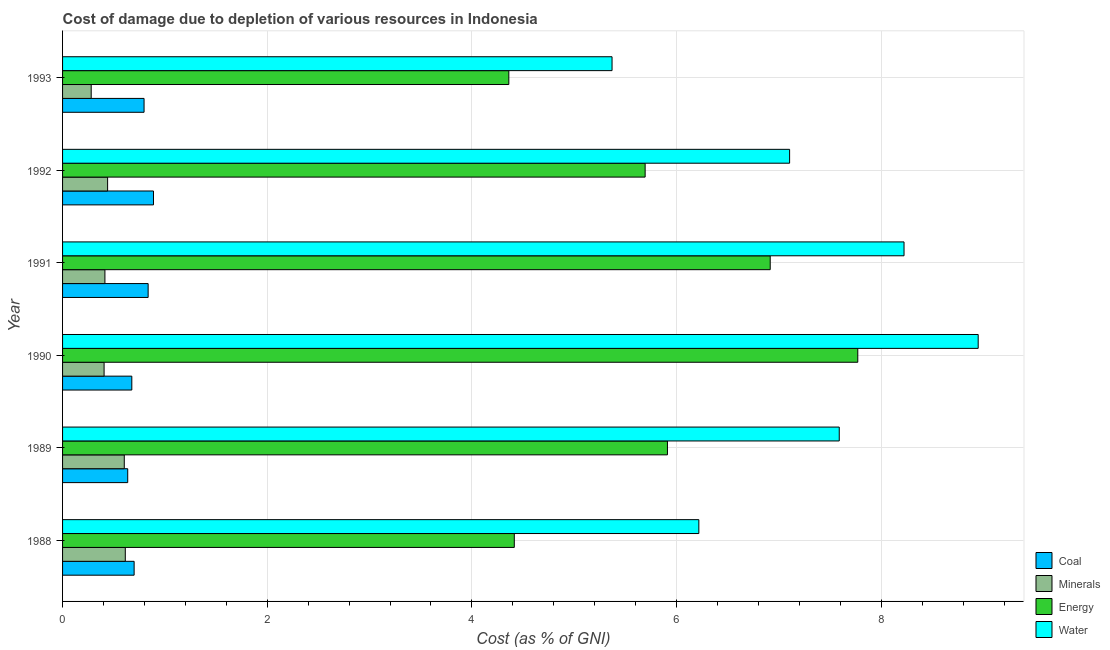How many different coloured bars are there?
Your answer should be very brief. 4. How many groups of bars are there?
Provide a succinct answer. 6. How many bars are there on the 5th tick from the bottom?
Make the answer very short. 4. What is the cost of damage due to depletion of water in 1990?
Give a very brief answer. 8.95. Across all years, what is the maximum cost of damage due to depletion of minerals?
Your response must be concise. 0.61. Across all years, what is the minimum cost of damage due to depletion of water?
Provide a succinct answer. 5.37. What is the total cost of damage due to depletion of coal in the graph?
Your response must be concise. 4.53. What is the difference between the cost of damage due to depletion of minerals in 1990 and that in 1993?
Provide a succinct answer. 0.13. What is the difference between the cost of damage due to depletion of minerals in 1992 and the cost of damage due to depletion of coal in 1993?
Your answer should be very brief. -0.36. What is the average cost of damage due to depletion of coal per year?
Give a very brief answer. 0.76. In the year 1988, what is the difference between the cost of damage due to depletion of energy and cost of damage due to depletion of coal?
Keep it short and to the point. 3.71. What is the ratio of the cost of damage due to depletion of energy in 1990 to that in 1991?
Provide a succinct answer. 1.12. Is the cost of damage due to depletion of minerals in 1990 less than that in 1992?
Offer a terse response. Yes. Is the difference between the cost of damage due to depletion of coal in 1988 and 1992 greater than the difference between the cost of damage due to depletion of energy in 1988 and 1992?
Your answer should be compact. Yes. What is the difference between the highest and the second highest cost of damage due to depletion of minerals?
Keep it short and to the point. 0.01. Is the sum of the cost of damage due to depletion of energy in 1988 and 1990 greater than the maximum cost of damage due to depletion of coal across all years?
Keep it short and to the point. Yes. Is it the case that in every year, the sum of the cost of damage due to depletion of minerals and cost of damage due to depletion of coal is greater than the sum of cost of damage due to depletion of energy and cost of damage due to depletion of water?
Keep it short and to the point. No. What does the 1st bar from the top in 1993 represents?
Your answer should be very brief. Water. What does the 2nd bar from the bottom in 1990 represents?
Your answer should be very brief. Minerals. Is it the case that in every year, the sum of the cost of damage due to depletion of coal and cost of damage due to depletion of minerals is greater than the cost of damage due to depletion of energy?
Your answer should be very brief. No. How many bars are there?
Make the answer very short. 24. Are the values on the major ticks of X-axis written in scientific E-notation?
Offer a very short reply. No. Does the graph contain any zero values?
Your answer should be very brief. No. What is the title of the graph?
Provide a short and direct response. Cost of damage due to depletion of various resources in Indonesia . What is the label or title of the X-axis?
Your answer should be very brief. Cost (as % of GNI). What is the Cost (as % of GNI) of Coal in 1988?
Provide a short and direct response. 0.7. What is the Cost (as % of GNI) of Minerals in 1988?
Your answer should be very brief. 0.61. What is the Cost (as % of GNI) in Energy in 1988?
Offer a terse response. 4.41. What is the Cost (as % of GNI) of Water in 1988?
Keep it short and to the point. 6.22. What is the Cost (as % of GNI) of Coal in 1989?
Offer a terse response. 0.64. What is the Cost (as % of GNI) in Minerals in 1989?
Ensure brevity in your answer.  0.6. What is the Cost (as % of GNI) of Energy in 1989?
Keep it short and to the point. 5.91. What is the Cost (as % of GNI) of Water in 1989?
Make the answer very short. 7.59. What is the Cost (as % of GNI) in Coal in 1990?
Make the answer very short. 0.68. What is the Cost (as % of GNI) of Minerals in 1990?
Your response must be concise. 0.41. What is the Cost (as % of GNI) in Energy in 1990?
Make the answer very short. 7.77. What is the Cost (as % of GNI) of Water in 1990?
Give a very brief answer. 8.95. What is the Cost (as % of GNI) of Coal in 1991?
Make the answer very short. 0.84. What is the Cost (as % of GNI) in Minerals in 1991?
Your response must be concise. 0.41. What is the Cost (as % of GNI) in Energy in 1991?
Provide a succinct answer. 6.92. What is the Cost (as % of GNI) of Water in 1991?
Offer a terse response. 8.22. What is the Cost (as % of GNI) of Coal in 1992?
Provide a succinct answer. 0.89. What is the Cost (as % of GNI) in Minerals in 1992?
Your response must be concise. 0.44. What is the Cost (as % of GNI) of Energy in 1992?
Ensure brevity in your answer.  5.69. What is the Cost (as % of GNI) in Water in 1992?
Provide a succinct answer. 7.1. What is the Cost (as % of GNI) of Coal in 1993?
Make the answer very short. 0.8. What is the Cost (as % of GNI) of Minerals in 1993?
Provide a short and direct response. 0.28. What is the Cost (as % of GNI) in Energy in 1993?
Give a very brief answer. 4.36. What is the Cost (as % of GNI) in Water in 1993?
Give a very brief answer. 5.37. Across all years, what is the maximum Cost (as % of GNI) in Coal?
Your answer should be compact. 0.89. Across all years, what is the maximum Cost (as % of GNI) in Minerals?
Your response must be concise. 0.61. Across all years, what is the maximum Cost (as % of GNI) of Energy?
Ensure brevity in your answer.  7.77. Across all years, what is the maximum Cost (as % of GNI) of Water?
Give a very brief answer. 8.95. Across all years, what is the minimum Cost (as % of GNI) of Coal?
Offer a terse response. 0.64. Across all years, what is the minimum Cost (as % of GNI) in Minerals?
Make the answer very short. 0.28. Across all years, what is the minimum Cost (as % of GNI) of Energy?
Offer a very short reply. 4.36. Across all years, what is the minimum Cost (as % of GNI) of Water?
Your answer should be compact. 5.37. What is the total Cost (as % of GNI) in Coal in the graph?
Your answer should be very brief. 4.53. What is the total Cost (as % of GNI) in Minerals in the graph?
Keep it short and to the point. 2.76. What is the total Cost (as % of GNI) of Energy in the graph?
Offer a very short reply. 35.07. What is the total Cost (as % of GNI) in Water in the graph?
Your answer should be very brief. 43.45. What is the difference between the Cost (as % of GNI) of Coal in 1988 and that in 1989?
Your answer should be compact. 0.06. What is the difference between the Cost (as % of GNI) of Minerals in 1988 and that in 1989?
Your answer should be very brief. 0.01. What is the difference between the Cost (as % of GNI) of Energy in 1988 and that in 1989?
Provide a short and direct response. -1.5. What is the difference between the Cost (as % of GNI) of Water in 1988 and that in 1989?
Your response must be concise. -1.37. What is the difference between the Cost (as % of GNI) in Coal in 1988 and that in 1990?
Provide a succinct answer. 0.02. What is the difference between the Cost (as % of GNI) in Minerals in 1988 and that in 1990?
Your answer should be compact. 0.21. What is the difference between the Cost (as % of GNI) of Energy in 1988 and that in 1990?
Provide a short and direct response. -3.36. What is the difference between the Cost (as % of GNI) of Water in 1988 and that in 1990?
Your response must be concise. -2.73. What is the difference between the Cost (as % of GNI) of Coal in 1988 and that in 1991?
Your answer should be very brief. -0.14. What is the difference between the Cost (as % of GNI) of Minerals in 1988 and that in 1991?
Your response must be concise. 0.2. What is the difference between the Cost (as % of GNI) of Energy in 1988 and that in 1991?
Your answer should be compact. -2.5. What is the difference between the Cost (as % of GNI) in Water in 1988 and that in 1991?
Keep it short and to the point. -2.01. What is the difference between the Cost (as % of GNI) of Coal in 1988 and that in 1992?
Provide a succinct answer. -0.19. What is the difference between the Cost (as % of GNI) in Minerals in 1988 and that in 1992?
Your answer should be very brief. 0.17. What is the difference between the Cost (as % of GNI) in Energy in 1988 and that in 1992?
Provide a succinct answer. -1.28. What is the difference between the Cost (as % of GNI) in Water in 1988 and that in 1992?
Ensure brevity in your answer.  -0.89. What is the difference between the Cost (as % of GNI) in Coal in 1988 and that in 1993?
Give a very brief answer. -0.1. What is the difference between the Cost (as % of GNI) of Minerals in 1988 and that in 1993?
Provide a short and direct response. 0.33. What is the difference between the Cost (as % of GNI) in Energy in 1988 and that in 1993?
Your answer should be very brief. 0.05. What is the difference between the Cost (as % of GNI) in Water in 1988 and that in 1993?
Your answer should be very brief. 0.85. What is the difference between the Cost (as % of GNI) of Coal in 1989 and that in 1990?
Your response must be concise. -0.04. What is the difference between the Cost (as % of GNI) in Minerals in 1989 and that in 1990?
Offer a very short reply. 0.2. What is the difference between the Cost (as % of GNI) in Energy in 1989 and that in 1990?
Your answer should be compact. -1.86. What is the difference between the Cost (as % of GNI) of Water in 1989 and that in 1990?
Offer a terse response. -1.36. What is the difference between the Cost (as % of GNI) of Coal in 1989 and that in 1991?
Provide a succinct answer. -0.2. What is the difference between the Cost (as % of GNI) of Minerals in 1989 and that in 1991?
Provide a short and direct response. 0.19. What is the difference between the Cost (as % of GNI) of Energy in 1989 and that in 1991?
Keep it short and to the point. -1. What is the difference between the Cost (as % of GNI) of Water in 1989 and that in 1991?
Your response must be concise. -0.63. What is the difference between the Cost (as % of GNI) in Coal in 1989 and that in 1992?
Make the answer very short. -0.25. What is the difference between the Cost (as % of GNI) in Minerals in 1989 and that in 1992?
Your answer should be very brief. 0.16. What is the difference between the Cost (as % of GNI) in Energy in 1989 and that in 1992?
Ensure brevity in your answer.  0.22. What is the difference between the Cost (as % of GNI) of Water in 1989 and that in 1992?
Your response must be concise. 0.49. What is the difference between the Cost (as % of GNI) of Coal in 1989 and that in 1993?
Provide a succinct answer. -0.16. What is the difference between the Cost (as % of GNI) in Minerals in 1989 and that in 1993?
Ensure brevity in your answer.  0.32. What is the difference between the Cost (as % of GNI) of Energy in 1989 and that in 1993?
Offer a terse response. 1.55. What is the difference between the Cost (as % of GNI) of Water in 1989 and that in 1993?
Provide a short and direct response. 2.22. What is the difference between the Cost (as % of GNI) in Coal in 1990 and that in 1991?
Your answer should be very brief. -0.16. What is the difference between the Cost (as % of GNI) of Minerals in 1990 and that in 1991?
Offer a very short reply. -0.01. What is the difference between the Cost (as % of GNI) in Energy in 1990 and that in 1991?
Offer a terse response. 0.86. What is the difference between the Cost (as % of GNI) in Water in 1990 and that in 1991?
Give a very brief answer. 0.72. What is the difference between the Cost (as % of GNI) of Coal in 1990 and that in 1992?
Make the answer very short. -0.21. What is the difference between the Cost (as % of GNI) in Minerals in 1990 and that in 1992?
Keep it short and to the point. -0.03. What is the difference between the Cost (as % of GNI) of Energy in 1990 and that in 1992?
Your answer should be compact. 2.08. What is the difference between the Cost (as % of GNI) of Water in 1990 and that in 1992?
Your answer should be very brief. 1.84. What is the difference between the Cost (as % of GNI) in Coal in 1990 and that in 1993?
Give a very brief answer. -0.12. What is the difference between the Cost (as % of GNI) in Minerals in 1990 and that in 1993?
Ensure brevity in your answer.  0.13. What is the difference between the Cost (as % of GNI) in Energy in 1990 and that in 1993?
Provide a succinct answer. 3.41. What is the difference between the Cost (as % of GNI) in Water in 1990 and that in 1993?
Ensure brevity in your answer.  3.58. What is the difference between the Cost (as % of GNI) of Coal in 1991 and that in 1992?
Your response must be concise. -0.05. What is the difference between the Cost (as % of GNI) of Minerals in 1991 and that in 1992?
Your answer should be compact. -0.03. What is the difference between the Cost (as % of GNI) in Energy in 1991 and that in 1992?
Provide a succinct answer. 1.22. What is the difference between the Cost (as % of GNI) of Water in 1991 and that in 1992?
Your answer should be very brief. 1.12. What is the difference between the Cost (as % of GNI) in Coal in 1991 and that in 1993?
Make the answer very short. 0.04. What is the difference between the Cost (as % of GNI) in Minerals in 1991 and that in 1993?
Provide a short and direct response. 0.13. What is the difference between the Cost (as % of GNI) of Energy in 1991 and that in 1993?
Offer a terse response. 2.55. What is the difference between the Cost (as % of GNI) of Water in 1991 and that in 1993?
Offer a very short reply. 2.85. What is the difference between the Cost (as % of GNI) of Coal in 1992 and that in 1993?
Your answer should be very brief. 0.09. What is the difference between the Cost (as % of GNI) in Minerals in 1992 and that in 1993?
Offer a terse response. 0.16. What is the difference between the Cost (as % of GNI) in Energy in 1992 and that in 1993?
Your response must be concise. 1.33. What is the difference between the Cost (as % of GNI) in Water in 1992 and that in 1993?
Ensure brevity in your answer.  1.74. What is the difference between the Cost (as % of GNI) in Coal in 1988 and the Cost (as % of GNI) in Minerals in 1989?
Offer a very short reply. 0.1. What is the difference between the Cost (as % of GNI) in Coal in 1988 and the Cost (as % of GNI) in Energy in 1989?
Give a very brief answer. -5.21. What is the difference between the Cost (as % of GNI) in Coal in 1988 and the Cost (as % of GNI) in Water in 1989?
Offer a very short reply. -6.89. What is the difference between the Cost (as % of GNI) of Minerals in 1988 and the Cost (as % of GNI) of Energy in 1989?
Provide a succinct answer. -5.3. What is the difference between the Cost (as % of GNI) of Minerals in 1988 and the Cost (as % of GNI) of Water in 1989?
Provide a short and direct response. -6.98. What is the difference between the Cost (as % of GNI) in Energy in 1988 and the Cost (as % of GNI) in Water in 1989?
Provide a short and direct response. -3.18. What is the difference between the Cost (as % of GNI) in Coal in 1988 and the Cost (as % of GNI) in Minerals in 1990?
Provide a succinct answer. 0.29. What is the difference between the Cost (as % of GNI) in Coal in 1988 and the Cost (as % of GNI) in Energy in 1990?
Your response must be concise. -7.07. What is the difference between the Cost (as % of GNI) in Coal in 1988 and the Cost (as % of GNI) in Water in 1990?
Make the answer very short. -8.25. What is the difference between the Cost (as % of GNI) of Minerals in 1988 and the Cost (as % of GNI) of Energy in 1990?
Provide a short and direct response. -7.16. What is the difference between the Cost (as % of GNI) in Minerals in 1988 and the Cost (as % of GNI) in Water in 1990?
Keep it short and to the point. -8.33. What is the difference between the Cost (as % of GNI) in Energy in 1988 and the Cost (as % of GNI) in Water in 1990?
Keep it short and to the point. -4.53. What is the difference between the Cost (as % of GNI) in Coal in 1988 and the Cost (as % of GNI) in Minerals in 1991?
Provide a succinct answer. 0.29. What is the difference between the Cost (as % of GNI) in Coal in 1988 and the Cost (as % of GNI) in Energy in 1991?
Ensure brevity in your answer.  -6.22. What is the difference between the Cost (as % of GNI) of Coal in 1988 and the Cost (as % of GNI) of Water in 1991?
Your answer should be very brief. -7.52. What is the difference between the Cost (as % of GNI) of Minerals in 1988 and the Cost (as % of GNI) of Energy in 1991?
Give a very brief answer. -6.3. What is the difference between the Cost (as % of GNI) of Minerals in 1988 and the Cost (as % of GNI) of Water in 1991?
Make the answer very short. -7.61. What is the difference between the Cost (as % of GNI) in Energy in 1988 and the Cost (as % of GNI) in Water in 1991?
Provide a short and direct response. -3.81. What is the difference between the Cost (as % of GNI) of Coal in 1988 and the Cost (as % of GNI) of Minerals in 1992?
Provide a short and direct response. 0.26. What is the difference between the Cost (as % of GNI) in Coal in 1988 and the Cost (as % of GNI) in Energy in 1992?
Make the answer very short. -4.99. What is the difference between the Cost (as % of GNI) of Coal in 1988 and the Cost (as % of GNI) of Water in 1992?
Give a very brief answer. -6.41. What is the difference between the Cost (as % of GNI) in Minerals in 1988 and the Cost (as % of GNI) in Energy in 1992?
Make the answer very short. -5.08. What is the difference between the Cost (as % of GNI) in Minerals in 1988 and the Cost (as % of GNI) in Water in 1992?
Give a very brief answer. -6.49. What is the difference between the Cost (as % of GNI) in Energy in 1988 and the Cost (as % of GNI) in Water in 1992?
Provide a short and direct response. -2.69. What is the difference between the Cost (as % of GNI) in Coal in 1988 and the Cost (as % of GNI) in Minerals in 1993?
Give a very brief answer. 0.42. What is the difference between the Cost (as % of GNI) in Coal in 1988 and the Cost (as % of GNI) in Energy in 1993?
Offer a terse response. -3.66. What is the difference between the Cost (as % of GNI) of Coal in 1988 and the Cost (as % of GNI) of Water in 1993?
Your answer should be very brief. -4.67. What is the difference between the Cost (as % of GNI) in Minerals in 1988 and the Cost (as % of GNI) in Energy in 1993?
Ensure brevity in your answer.  -3.75. What is the difference between the Cost (as % of GNI) in Minerals in 1988 and the Cost (as % of GNI) in Water in 1993?
Your response must be concise. -4.76. What is the difference between the Cost (as % of GNI) in Energy in 1988 and the Cost (as % of GNI) in Water in 1993?
Offer a very short reply. -0.96. What is the difference between the Cost (as % of GNI) in Coal in 1989 and the Cost (as % of GNI) in Minerals in 1990?
Your response must be concise. 0.23. What is the difference between the Cost (as % of GNI) in Coal in 1989 and the Cost (as % of GNI) in Energy in 1990?
Make the answer very short. -7.13. What is the difference between the Cost (as % of GNI) of Coal in 1989 and the Cost (as % of GNI) of Water in 1990?
Your answer should be compact. -8.31. What is the difference between the Cost (as % of GNI) of Minerals in 1989 and the Cost (as % of GNI) of Energy in 1990?
Provide a succinct answer. -7.17. What is the difference between the Cost (as % of GNI) in Minerals in 1989 and the Cost (as % of GNI) in Water in 1990?
Offer a terse response. -8.34. What is the difference between the Cost (as % of GNI) of Energy in 1989 and the Cost (as % of GNI) of Water in 1990?
Ensure brevity in your answer.  -3.04. What is the difference between the Cost (as % of GNI) of Coal in 1989 and the Cost (as % of GNI) of Minerals in 1991?
Offer a very short reply. 0.22. What is the difference between the Cost (as % of GNI) in Coal in 1989 and the Cost (as % of GNI) in Energy in 1991?
Provide a short and direct response. -6.28. What is the difference between the Cost (as % of GNI) of Coal in 1989 and the Cost (as % of GNI) of Water in 1991?
Your answer should be compact. -7.59. What is the difference between the Cost (as % of GNI) in Minerals in 1989 and the Cost (as % of GNI) in Energy in 1991?
Offer a very short reply. -6.31. What is the difference between the Cost (as % of GNI) in Minerals in 1989 and the Cost (as % of GNI) in Water in 1991?
Your answer should be very brief. -7.62. What is the difference between the Cost (as % of GNI) in Energy in 1989 and the Cost (as % of GNI) in Water in 1991?
Keep it short and to the point. -2.31. What is the difference between the Cost (as % of GNI) in Coal in 1989 and the Cost (as % of GNI) in Minerals in 1992?
Ensure brevity in your answer.  0.2. What is the difference between the Cost (as % of GNI) of Coal in 1989 and the Cost (as % of GNI) of Energy in 1992?
Provide a short and direct response. -5.06. What is the difference between the Cost (as % of GNI) of Coal in 1989 and the Cost (as % of GNI) of Water in 1992?
Offer a very short reply. -6.47. What is the difference between the Cost (as % of GNI) in Minerals in 1989 and the Cost (as % of GNI) in Energy in 1992?
Offer a very short reply. -5.09. What is the difference between the Cost (as % of GNI) of Minerals in 1989 and the Cost (as % of GNI) of Water in 1992?
Your answer should be compact. -6.5. What is the difference between the Cost (as % of GNI) in Energy in 1989 and the Cost (as % of GNI) in Water in 1992?
Make the answer very short. -1.19. What is the difference between the Cost (as % of GNI) of Coal in 1989 and the Cost (as % of GNI) of Minerals in 1993?
Offer a very short reply. 0.36. What is the difference between the Cost (as % of GNI) of Coal in 1989 and the Cost (as % of GNI) of Energy in 1993?
Your answer should be compact. -3.72. What is the difference between the Cost (as % of GNI) in Coal in 1989 and the Cost (as % of GNI) in Water in 1993?
Provide a short and direct response. -4.73. What is the difference between the Cost (as % of GNI) in Minerals in 1989 and the Cost (as % of GNI) in Energy in 1993?
Offer a very short reply. -3.76. What is the difference between the Cost (as % of GNI) of Minerals in 1989 and the Cost (as % of GNI) of Water in 1993?
Offer a very short reply. -4.77. What is the difference between the Cost (as % of GNI) of Energy in 1989 and the Cost (as % of GNI) of Water in 1993?
Your answer should be compact. 0.54. What is the difference between the Cost (as % of GNI) of Coal in 1990 and the Cost (as % of GNI) of Minerals in 1991?
Ensure brevity in your answer.  0.26. What is the difference between the Cost (as % of GNI) of Coal in 1990 and the Cost (as % of GNI) of Energy in 1991?
Make the answer very short. -6.24. What is the difference between the Cost (as % of GNI) of Coal in 1990 and the Cost (as % of GNI) of Water in 1991?
Offer a terse response. -7.55. What is the difference between the Cost (as % of GNI) in Minerals in 1990 and the Cost (as % of GNI) in Energy in 1991?
Provide a succinct answer. -6.51. What is the difference between the Cost (as % of GNI) of Minerals in 1990 and the Cost (as % of GNI) of Water in 1991?
Your answer should be very brief. -7.82. What is the difference between the Cost (as % of GNI) in Energy in 1990 and the Cost (as % of GNI) in Water in 1991?
Keep it short and to the point. -0.45. What is the difference between the Cost (as % of GNI) of Coal in 1990 and the Cost (as % of GNI) of Minerals in 1992?
Ensure brevity in your answer.  0.24. What is the difference between the Cost (as % of GNI) of Coal in 1990 and the Cost (as % of GNI) of Energy in 1992?
Make the answer very short. -5.02. What is the difference between the Cost (as % of GNI) in Coal in 1990 and the Cost (as % of GNI) in Water in 1992?
Make the answer very short. -6.43. What is the difference between the Cost (as % of GNI) of Minerals in 1990 and the Cost (as % of GNI) of Energy in 1992?
Ensure brevity in your answer.  -5.29. What is the difference between the Cost (as % of GNI) in Minerals in 1990 and the Cost (as % of GNI) in Water in 1992?
Provide a short and direct response. -6.7. What is the difference between the Cost (as % of GNI) in Energy in 1990 and the Cost (as % of GNI) in Water in 1992?
Provide a short and direct response. 0.67. What is the difference between the Cost (as % of GNI) of Coal in 1990 and the Cost (as % of GNI) of Minerals in 1993?
Give a very brief answer. 0.4. What is the difference between the Cost (as % of GNI) of Coal in 1990 and the Cost (as % of GNI) of Energy in 1993?
Give a very brief answer. -3.68. What is the difference between the Cost (as % of GNI) of Coal in 1990 and the Cost (as % of GNI) of Water in 1993?
Give a very brief answer. -4.69. What is the difference between the Cost (as % of GNI) of Minerals in 1990 and the Cost (as % of GNI) of Energy in 1993?
Provide a succinct answer. -3.96. What is the difference between the Cost (as % of GNI) in Minerals in 1990 and the Cost (as % of GNI) in Water in 1993?
Your response must be concise. -4.96. What is the difference between the Cost (as % of GNI) of Energy in 1990 and the Cost (as % of GNI) of Water in 1993?
Your answer should be compact. 2.4. What is the difference between the Cost (as % of GNI) of Coal in 1991 and the Cost (as % of GNI) of Minerals in 1992?
Ensure brevity in your answer.  0.4. What is the difference between the Cost (as % of GNI) of Coal in 1991 and the Cost (as % of GNI) of Energy in 1992?
Keep it short and to the point. -4.86. What is the difference between the Cost (as % of GNI) of Coal in 1991 and the Cost (as % of GNI) of Water in 1992?
Ensure brevity in your answer.  -6.27. What is the difference between the Cost (as % of GNI) of Minerals in 1991 and the Cost (as % of GNI) of Energy in 1992?
Offer a terse response. -5.28. What is the difference between the Cost (as % of GNI) in Minerals in 1991 and the Cost (as % of GNI) in Water in 1992?
Give a very brief answer. -6.69. What is the difference between the Cost (as % of GNI) in Energy in 1991 and the Cost (as % of GNI) in Water in 1992?
Your response must be concise. -0.19. What is the difference between the Cost (as % of GNI) in Coal in 1991 and the Cost (as % of GNI) in Minerals in 1993?
Provide a short and direct response. 0.56. What is the difference between the Cost (as % of GNI) of Coal in 1991 and the Cost (as % of GNI) of Energy in 1993?
Your response must be concise. -3.52. What is the difference between the Cost (as % of GNI) of Coal in 1991 and the Cost (as % of GNI) of Water in 1993?
Your answer should be compact. -4.53. What is the difference between the Cost (as % of GNI) in Minerals in 1991 and the Cost (as % of GNI) in Energy in 1993?
Your answer should be compact. -3.95. What is the difference between the Cost (as % of GNI) of Minerals in 1991 and the Cost (as % of GNI) of Water in 1993?
Your answer should be compact. -4.96. What is the difference between the Cost (as % of GNI) of Energy in 1991 and the Cost (as % of GNI) of Water in 1993?
Ensure brevity in your answer.  1.55. What is the difference between the Cost (as % of GNI) in Coal in 1992 and the Cost (as % of GNI) in Minerals in 1993?
Keep it short and to the point. 0.61. What is the difference between the Cost (as % of GNI) of Coal in 1992 and the Cost (as % of GNI) of Energy in 1993?
Offer a very short reply. -3.47. What is the difference between the Cost (as % of GNI) of Coal in 1992 and the Cost (as % of GNI) of Water in 1993?
Offer a terse response. -4.48. What is the difference between the Cost (as % of GNI) in Minerals in 1992 and the Cost (as % of GNI) in Energy in 1993?
Provide a short and direct response. -3.92. What is the difference between the Cost (as % of GNI) in Minerals in 1992 and the Cost (as % of GNI) in Water in 1993?
Your answer should be very brief. -4.93. What is the difference between the Cost (as % of GNI) of Energy in 1992 and the Cost (as % of GNI) of Water in 1993?
Offer a very short reply. 0.32. What is the average Cost (as % of GNI) in Coal per year?
Keep it short and to the point. 0.76. What is the average Cost (as % of GNI) of Minerals per year?
Offer a terse response. 0.46. What is the average Cost (as % of GNI) of Energy per year?
Ensure brevity in your answer.  5.84. What is the average Cost (as % of GNI) of Water per year?
Offer a terse response. 7.24. In the year 1988, what is the difference between the Cost (as % of GNI) in Coal and Cost (as % of GNI) in Minerals?
Your response must be concise. 0.09. In the year 1988, what is the difference between the Cost (as % of GNI) of Coal and Cost (as % of GNI) of Energy?
Provide a short and direct response. -3.71. In the year 1988, what is the difference between the Cost (as % of GNI) in Coal and Cost (as % of GNI) in Water?
Make the answer very short. -5.52. In the year 1988, what is the difference between the Cost (as % of GNI) in Minerals and Cost (as % of GNI) in Energy?
Give a very brief answer. -3.8. In the year 1988, what is the difference between the Cost (as % of GNI) in Minerals and Cost (as % of GNI) in Water?
Provide a short and direct response. -5.6. In the year 1988, what is the difference between the Cost (as % of GNI) in Energy and Cost (as % of GNI) in Water?
Give a very brief answer. -1.8. In the year 1989, what is the difference between the Cost (as % of GNI) of Coal and Cost (as % of GNI) of Minerals?
Your response must be concise. 0.03. In the year 1989, what is the difference between the Cost (as % of GNI) in Coal and Cost (as % of GNI) in Energy?
Keep it short and to the point. -5.27. In the year 1989, what is the difference between the Cost (as % of GNI) in Coal and Cost (as % of GNI) in Water?
Provide a succinct answer. -6.95. In the year 1989, what is the difference between the Cost (as % of GNI) of Minerals and Cost (as % of GNI) of Energy?
Your answer should be very brief. -5.31. In the year 1989, what is the difference between the Cost (as % of GNI) in Minerals and Cost (as % of GNI) in Water?
Your answer should be very brief. -6.99. In the year 1989, what is the difference between the Cost (as % of GNI) in Energy and Cost (as % of GNI) in Water?
Provide a short and direct response. -1.68. In the year 1990, what is the difference between the Cost (as % of GNI) in Coal and Cost (as % of GNI) in Minerals?
Your answer should be very brief. 0.27. In the year 1990, what is the difference between the Cost (as % of GNI) in Coal and Cost (as % of GNI) in Energy?
Provide a short and direct response. -7.09. In the year 1990, what is the difference between the Cost (as % of GNI) in Coal and Cost (as % of GNI) in Water?
Keep it short and to the point. -8.27. In the year 1990, what is the difference between the Cost (as % of GNI) in Minerals and Cost (as % of GNI) in Energy?
Give a very brief answer. -7.37. In the year 1990, what is the difference between the Cost (as % of GNI) in Minerals and Cost (as % of GNI) in Water?
Offer a terse response. -8.54. In the year 1990, what is the difference between the Cost (as % of GNI) of Energy and Cost (as % of GNI) of Water?
Ensure brevity in your answer.  -1.18. In the year 1991, what is the difference between the Cost (as % of GNI) of Coal and Cost (as % of GNI) of Minerals?
Keep it short and to the point. 0.42. In the year 1991, what is the difference between the Cost (as % of GNI) of Coal and Cost (as % of GNI) of Energy?
Give a very brief answer. -6.08. In the year 1991, what is the difference between the Cost (as % of GNI) in Coal and Cost (as % of GNI) in Water?
Your answer should be very brief. -7.39. In the year 1991, what is the difference between the Cost (as % of GNI) of Minerals and Cost (as % of GNI) of Energy?
Ensure brevity in your answer.  -6.5. In the year 1991, what is the difference between the Cost (as % of GNI) in Minerals and Cost (as % of GNI) in Water?
Keep it short and to the point. -7.81. In the year 1991, what is the difference between the Cost (as % of GNI) of Energy and Cost (as % of GNI) of Water?
Your answer should be compact. -1.31. In the year 1992, what is the difference between the Cost (as % of GNI) in Coal and Cost (as % of GNI) in Minerals?
Provide a succinct answer. 0.45. In the year 1992, what is the difference between the Cost (as % of GNI) of Coal and Cost (as % of GNI) of Energy?
Provide a short and direct response. -4.8. In the year 1992, what is the difference between the Cost (as % of GNI) of Coal and Cost (as % of GNI) of Water?
Keep it short and to the point. -6.22. In the year 1992, what is the difference between the Cost (as % of GNI) of Minerals and Cost (as % of GNI) of Energy?
Make the answer very short. -5.25. In the year 1992, what is the difference between the Cost (as % of GNI) in Minerals and Cost (as % of GNI) in Water?
Offer a very short reply. -6.66. In the year 1992, what is the difference between the Cost (as % of GNI) in Energy and Cost (as % of GNI) in Water?
Provide a short and direct response. -1.41. In the year 1993, what is the difference between the Cost (as % of GNI) in Coal and Cost (as % of GNI) in Minerals?
Your answer should be very brief. 0.52. In the year 1993, what is the difference between the Cost (as % of GNI) in Coal and Cost (as % of GNI) in Energy?
Your response must be concise. -3.56. In the year 1993, what is the difference between the Cost (as % of GNI) of Coal and Cost (as % of GNI) of Water?
Offer a very short reply. -4.57. In the year 1993, what is the difference between the Cost (as % of GNI) of Minerals and Cost (as % of GNI) of Energy?
Your response must be concise. -4.08. In the year 1993, what is the difference between the Cost (as % of GNI) of Minerals and Cost (as % of GNI) of Water?
Offer a very short reply. -5.09. In the year 1993, what is the difference between the Cost (as % of GNI) of Energy and Cost (as % of GNI) of Water?
Provide a short and direct response. -1.01. What is the ratio of the Cost (as % of GNI) in Coal in 1988 to that in 1989?
Your answer should be very brief. 1.1. What is the ratio of the Cost (as % of GNI) in Minerals in 1988 to that in 1989?
Your answer should be compact. 1.02. What is the ratio of the Cost (as % of GNI) of Energy in 1988 to that in 1989?
Ensure brevity in your answer.  0.75. What is the ratio of the Cost (as % of GNI) of Water in 1988 to that in 1989?
Offer a terse response. 0.82. What is the ratio of the Cost (as % of GNI) in Coal in 1988 to that in 1990?
Offer a very short reply. 1.03. What is the ratio of the Cost (as % of GNI) of Minerals in 1988 to that in 1990?
Your response must be concise. 1.51. What is the ratio of the Cost (as % of GNI) in Energy in 1988 to that in 1990?
Offer a terse response. 0.57. What is the ratio of the Cost (as % of GNI) in Water in 1988 to that in 1990?
Provide a succinct answer. 0.69. What is the ratio of the Cost (as % of GNI) of Coal in 1988 to that in 1991?
Offer a very short reply. 0.84. What is the ratio of the Cost (as % of GNI) of Minerals in 1988 to that in 1991?
Provide a short and direct response. 1.48. What is the ratio of the Cost (as % of GNI) in Energy in 1988 to that in 1991?
Offer a very short reply. 0.64. What is the ratio of the Cost (as % of GNI) of Water in 1988 to that in 1991?
Your answer should be very brief. 0.76. What is the ratio of the Cost (as % of GNI) in Coal in 1988 to that in 1992?
Offer a terse response. 0.79. What is the ratio of the Cost (as % of GNI) in Minerals in 1988 to that in 1992?
Ensure brevity in your answer.  1.39. What is the ratio of the Cost (as % of GNI) of Energy in 1988 to that in 1992?
Your response must be concise. 0.78. What is the ratio of the Cost (as % of GNI) in Water in 1988 to that in 1992?
Offer a very short reply. 0.88. What is the ratio of the Cost (as % of GNI) in Coal in 1988 to that in 1993?
Ensure brevity in your answer.  0.88. What is the ratio of the Cost (as % of GNI) in Minerals in 1988 to that in 1993?
Your answer should be compact. 2.19. What is the ratio of the Cost (as % of GNI) in Energy in 1988 to that in 1993?
Make the answer very short. 1.01. What is the ratio of the Cost (as % of GNI) of Water in 1988 to that in 1993?
Give a very brief answer. 1.16. What is the ratio of the Cost (as % of GNI) in Coal in 1989 to that in 1990?
Keep it short and to the point. 0.94. What is the ratio of the Cost (as % of GNI) of Minerals in 1989 to that in 1990?
Your answer should be very brief. 1.49. What is the ratio of the Cost (as % of GNI) of Energy in 1989 to that in 1990?
Your answer should be very brief. 0.76. What is the ratio of the Cost (as % of GNI) in Water in 1989 to that in 1990?
Offer a very short reply. 0.85. What is the ratio of the Cost (as % of GNI) of Coal in 1989 to that in 1991?
Offer a very short reply. 0.76. What is the ratio of the Cost (as % of GNI) of Minerals in 1989 to that in 1991?
Offer a very short reply. 1.46. What is the ratio of the Cost (as % of GNI) of Energy in 1989 to that in 1991?
Give a very brief answer. 0.85. What is the ratio of the Cost (as % of GNI) in Water in 1989 to that in 1991?
Give a very brief answer. 0.92. What is the ratio of the Cost (as % of GNI) in Coal in 1989 to that in 1992?
Ensure brevity in your answer.  0.72. What is the ratio of the Cost (as % of GNI) in Minerals in 1989 to that in 1992?
Your answer should be compact. 1.37. What is the ratio of the Cost (as % of GNI) of Energy in 1989 to that in 1992?
Your answer should be very brief. 1.04. What is the ratio of the Cost (as % of GNI) in Water in 1989 to that in 1992?
Provide a short and direct response. 1.07. What is the ratio of the Cost (as % of GNI) in Coal in 1989 to that in 1993?
Make the answer very short. 0.8. What is the ratio of the Cost (as % of GNI) in Minerals in 1989 to that in 1993?
Provide a short and direct response. 2.16. What is the ratio of the Cost (as % of GNI) in Energy in 1989 to that in 1993?
Provide a succinct answer. 1.36. What is the ratio of the Cost (as % of GNI) of Water in 1989 to that in 1993?
Your answer should be very brief. 1.41. What is the ratio of the Cost (as % of GNI) in Coal in 1990 to that in 1991?
Give a very brief answer. 0.81. What is the ratio of the Cost (as % of GNI) of Minerals in 1990 to that in 1991?
Your response must be concise. 0.98. What is the ratio of the Cost (as % of GNI) of Energy in 1990 to that in 1991?
Your answer should be very brief. 1.12. What is the ratio of the Cost (as % of GNI) in Water in 1990 to that in 1991?
Your response must be concise. 1.09. What is the ratio of the Cost (as % of GNI) in Coal in 1990 to that in 1992?
Offer a terse response. 0.76. What is the ratio of the Cost (as % of GNI) in Minerals in 1990 to that in 1992?
Offer a terse response. 0.92. What is the ratio of the Cost (as % of GNI) in Energy in 1990 to that in 1992?
Make the answer very short. 1.36. What is the ratio of the Cost (as % of GNI) in Water in 1990 to that in 1992?
Offer a very short reply. 1.26. What is the ratio of the Cost (as % of GNI) of Coal in 1990 to that in 1993?
Your response must be concise. 0.85. What is the ratio of the Cost (as % of GNI) of Minerals in 1990 to that in 1993?
Your answer should be compact. 1.45. What is the ratio of the Cost (as % of GNI) of Energy in 1990 to that in 1993?
Ensure brevity in your answer.  1.78. What is the ratio of the Cost (as % of GNI) in Water in 1990 to that in 1993?
Offer a very short reply. 1.67. What is the ratio of the Cost (as % of GNI) in Coal in 1991 to that in 1992?
Ensure brevity in your answer.  0.94. What is the ratio of the Cost (as % of GNI) in Minerals in 1991 to that in 1992?
Make the answer very short. 0.94. What is the ratio of the Cost (as % of GNI) of Energy in 1991 to that in 1992?
Keep it short and to the point. 1.21. What is the ratio of the Cost (as % of GNI) of Water in 1991 to that in 1992?
Offer a very short reply. 1.16. What is the ratio of the Cost (as % of GNI) in Coal in 1991 to that in 1993?
Offer a very short reply. 1.05. What is the ratio of the Cost (as % of GNI) in Minerals in 1991 to that in 1993?
Provide a short and direct response. 1.48. What is the ratio of the Cost (as % of GNI) in Energy in 1991 to that in 1993?
Make the answer very short. 1.59. What is the ratio of the Cost (as % of GNI) of Water in 1991 to that in 1993?
Provide a succinct answer. 1.53. What is the ratio of the Cost (as % of GNI) in Coal in 1992 to that in 1993?
Give a very brief answer. 1.12. What is the ratio of the Cost (as % of GNI) of Minerals in 1992 to that in 1993?
Offer a terse response. 1.57. What is the ratio of the Cost (as % of GNI) of Energy in 1992 to that in 1993?
Your answer should be compact. 1.31. What is the ratio of the Cost (as % of GNI) of Water in 1992 to that in 1993?
Keep it short and to the point. 1.32. What is the difference between the highest and the second highest Cost (as % of GNI) in Coal?
Your answer should be very brief. 0.05. What is the difference between the highest and the second highest Cost (as % of GNI) of Minerals?
Your answer should be compact. 0.01. What is the difference between the highest and the second highest Cost (as % of GNI) in Energy?
Keep it short and to the point. 0.86. What is the difference between the highest and the second highest Cost (as % of GNI) in Water?
Make the answer very short. 0.72. What is the difference between the highest and the lowest Cost (as % of GNI) in Coal?
Your answer should be compact. 0.25. What is the difference between the highest and the lowest Cost (as % of GNI) of Minerals?
Your answer should be very brief. 0.33. What is the difference between the highest and the lowest Cost (as % of GNI) in Energy?
Offer a very short reply. 3.41. What is the difference between the highest and the lowest Cost (as % of GNI) in Water?
Ensure brevity in your answer.  3.58. 